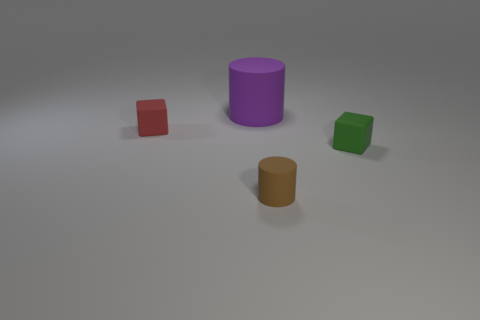There is a big rubber cylinder; are there any tiny green cubes to the left of it?
Ensure brevity in your answer.  No. Is the number of matte things behind the small red object greater than the number of green things to the left of the big purple rubber thing?
Your response must be concise. Yes. The other object that is the same shape as the tiny brown rubber object is what size?
Give a very brief answer. Large. How many cylinders are large things or rubber objects?
Provide a short and direct response. 2. Are there fewer small red objects that are behind the red block than rubber things behind the small cylinder?
Offer a terse response. Yes. What number of objects are objects that are in front of the red object or large metallic cylinders?
Give a very brief answer. 2. There is a object that is to the right of the matte cylinder that is in front of the tiny green thing; what is its shape?
Provide a short and direct response. Cube. Are there any rubber cubes that have the same size as the red thing?
Offer a very short reply. Yes. Are there more green blocks than big green shiny balls?
Offer a terse response. Yes. Is the size of the block on the right side of the red block the same as the rubber cylinder in front of the tiny red object?
Offer a terse response. Yes. 